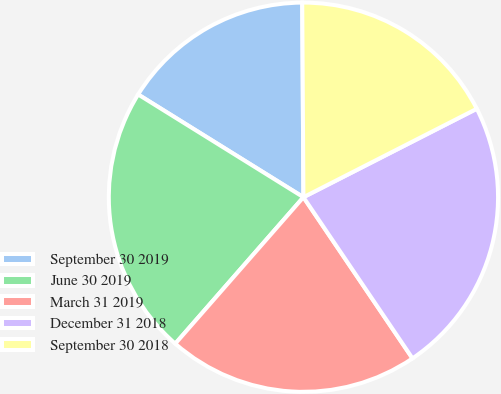Convert chart to OTSL. <chart><loc_0><loc_0><loc_500><loc_500><pie_chart><fcel>September 30 2019<fcel>June 30 2019<fcel>March 31 2019<fcel>December 31 2018<fcel>September 30 2018<nl><fcel>16.05%<fcel>22.41%<fcel>20.91%<fcel>23.04%<fcel>17.59%<nl></chart> 